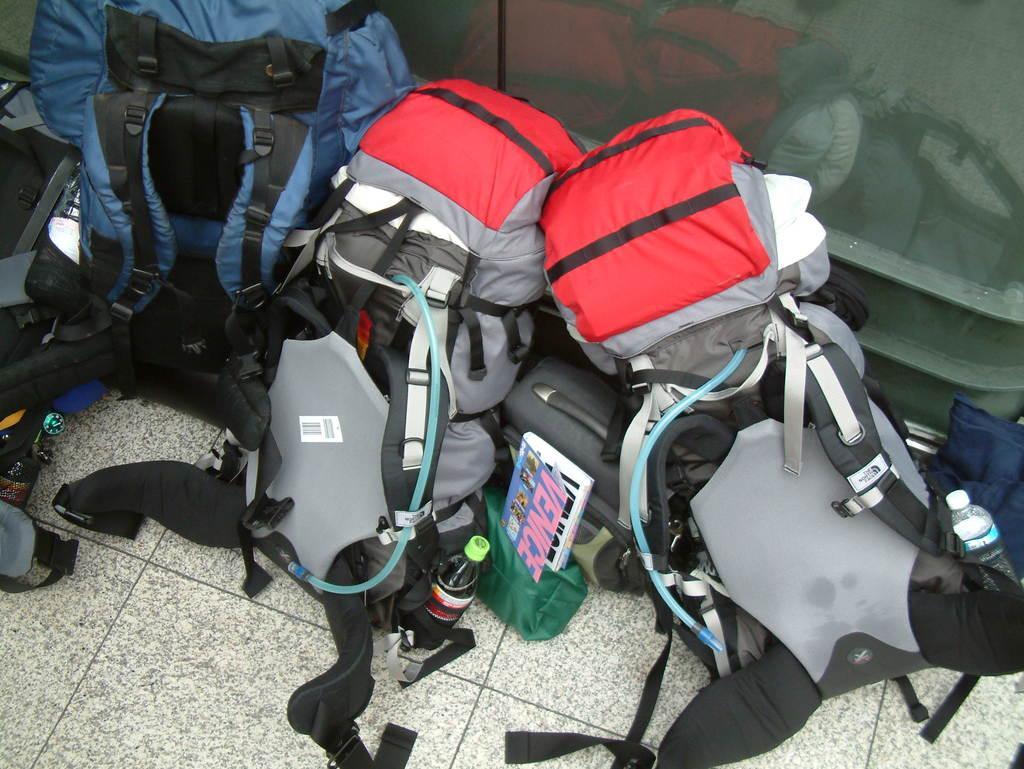Can you describe this image briefly? As we can see in the image there are travelling bags which are kept on the ground. 